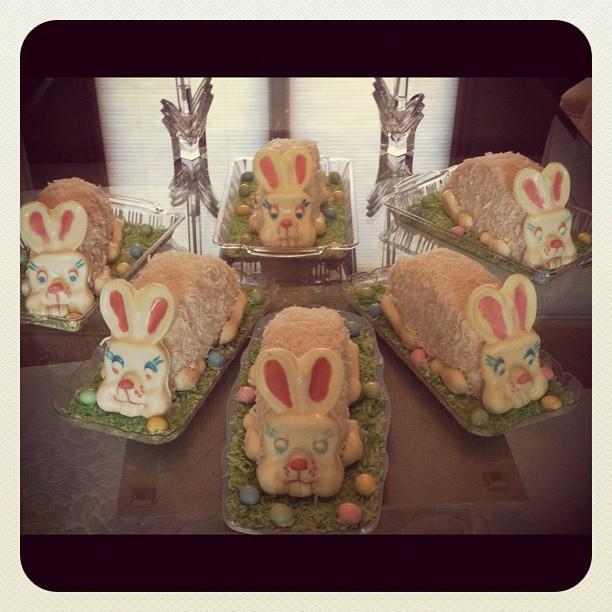How many cakes are there?
Give a very brief answer. 6. How many zebras are there?
Give a very brief answer. 0. 